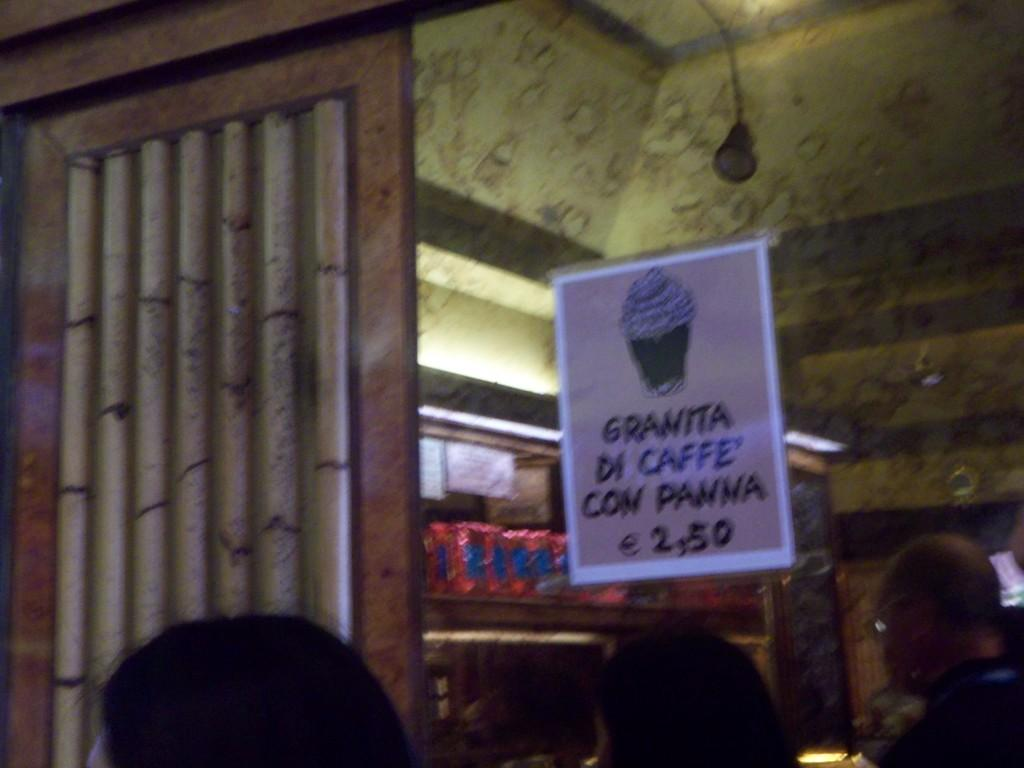What is attached to the transparent glass in the image? There is a poster attached to the transparent glass in the image. Can you describe the people in the image? There are people in the image, but their specific characteristics are not mentioned in the facts. What type of architectural feature is visible in the image? There are walls visible in the image. What other objects can be seen in the image besides the poster and people? There are other objects present in the image, but their specific details are not mentioned in the facts. What type of tooth is visible in the image? There is no tooth present in the image. What is the daughter of the person in the image doing? There is no mention of a daughter or any specific person in the image, so it is not possible to answer this question. 